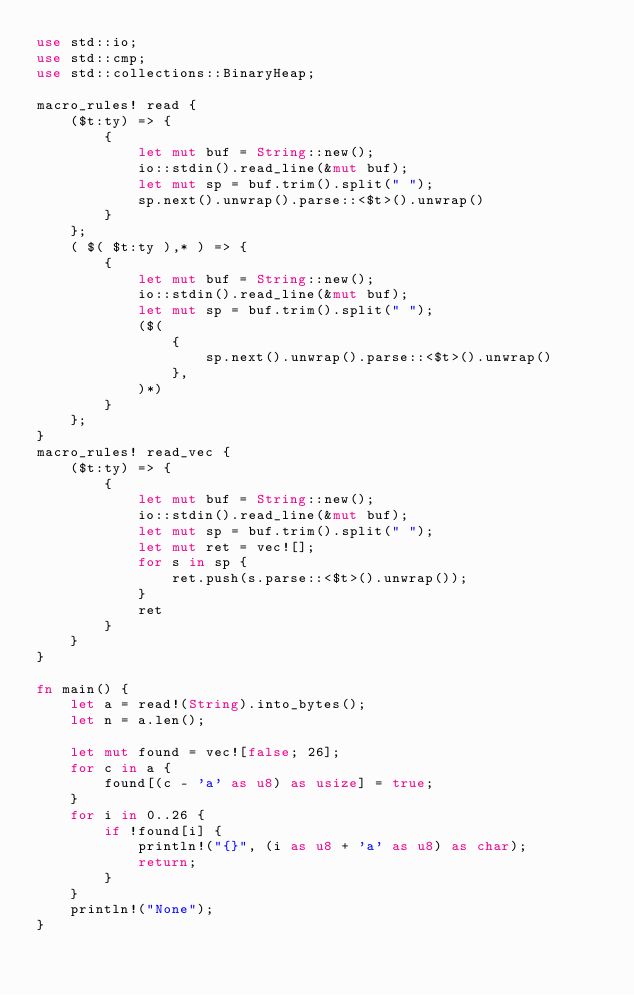Convert code to text. <code><loc_0><loc_0><loc_500><loc_500><_Rust_>use std::io;
use std::cmp;
use std::collections::BinaryHeap;

macro_rules! read {
    ($t:ty) => {
        {
            let mut buf = String::new();
            io::stdin().read_line(&mut buf);
            let mut sp = buf.trim().split(" ");
            sp.next().unwrap().parse::<$t>().unwrap()
        }
    };
    ( $( $t:ty ),* ) => {
        {
            let mut buf = String::new();
            io::stdin().read_line(&mut buf);
            let mut sp = buf.trim().split(" ");
            ($(
                {
                    sp.next().unwrap().parse::<$t>().unwrap()
                },
            )*)
        }
    };
}
macro_rules! read_vec {
    ($t:ty) => {
        {
            let mut buf = String::new();
            io::stdin().read_line(&mut buf);
            let mut sp = buf.trim().split(" ");
            let mut ret = vec![];
            for s in sp {
                ret.push(s.parse::<$t>().unwrap());
            }
            ret
        }
    }
}

fn main() {
    let a = read!(String).into_bytes();
    let n = a.len();

    let mut found = vec![false; 26];
    for c in a {
        found[(c - 'a' as u8) as usize] = true;
    }
    for i in 0..26 {
        if !found[i] {
            println!("{}", (i as u8 + 'a' as u8) as char);
            return;
        }
    }
    println!("None");
}
</code> 